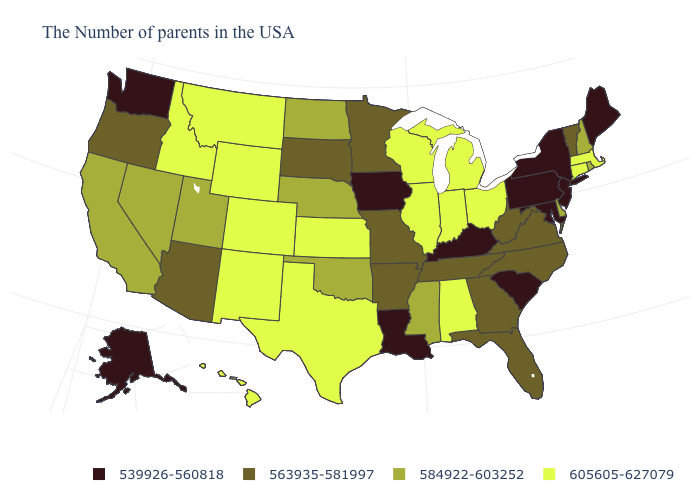Does California have a higher value than Maryland?
Concise answer only. Yes. What is the value of Kansas?
Quick response, please. 605605-627079. Name the states that have a value in the range 605605-627079?
Give a very brief answer. Massachusetts, Connecticut, Ohio, Michigan, Indiana, Alabama, Wisconsin, Illinois, Kansas, Texas, Wyoming, Colorado, New Mexico, Montana, Idaho, Hawaii. Name the states that have a value in the range 563935-581997?
Quick response, please. Vermont, Virginia, North Carolina, West Virginia, Florida, Georgia, Tennessee, Missouri, Arkansas, Minnesota, South Dakota, Arizona, Oregon. Does Maryland have the lowest value in the South?
Write a very short answer. Yes. What is the value of North Carolina?
Quick response, please. 563935-581997. What is the value of Georgia?
Be succinct. 563935-581997. What is the value of North Carolina?
Keep it brief. 563935-581997. What is the value of North Dakota?
Quick response, please. 584922-603252. Name the states that have a value in the range 605605-627079?
Give a very brief answer. Massachusetts, Connecticut, Ohio, Michigan, Indiana, Alabama, Wisconsin, Illinois, Kansas, Texas, Wyoming, Colorado, New Mexico, Montana, Idaho, Hawaii. Among the states that border Florida , which have the highest value?
Keep it brief. Alabama. Name the states that have a value in the range 539926-560818?
Keep it brief. Maine, New York, New Jersey, Maryland, Pennsylvania, South Carolina, Kentucky, Louisiana, Iowa, Washington, Alaska. What is the highest value in states that border Mississippi?
Give a very brief answer. 605605-627079. Which states have the lowest value in the USA?
Answer briefly. Maine, New York, New Jersey, Maryland, Pennsylvania, South Carolina, Kentucky, Louisiana, Iowa, Washington, Alaska. Does the map have missing data?
Write a very short answer. No. 